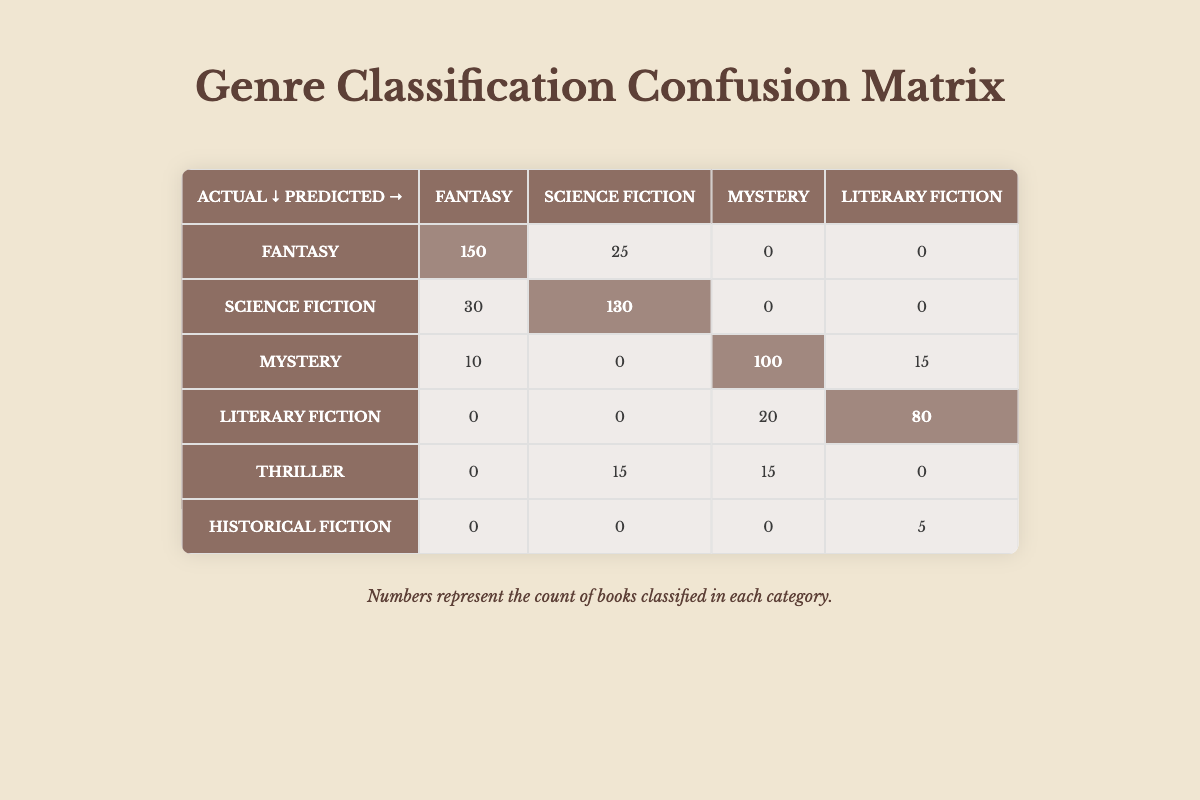What is the count of books that were correctly classified as Fantasy? The matrix indicates that 150 books were predicted as Fantasy and were also actual Fantasy. Therefore, the count of correctly classified Fantasy books is directly from the diagonal element of the matrix.
Answer: 150 What is the total number of books classified as Mystery? To find the total number of books classified as Mystery, we need to sum up all the counts in the Mystery column. This includes 100 (correctly classified), 20 (Literary Fiction predicted as Mystery), and 15 (Thriller predicted as Mystery). Therefore, the total is 100 + 20 + 15 = 135.
Answer: 135 Was the count of Science Fiction books incorrectly classified as Fantasy greater than those incorrectly classified as Mystery? The count of Science Fiction classified as Fantasy is 25, while the count of Science Fiction classified as Mystery is 0. Since 25 is greater than 0, the statement is true.
Answer: Yes What percentage of books in the Literary Fiction category were incorrectly classified? To find this percentage, first, calculate the total number of Literary Fiction: it is 80 (correctly classified) + 15 (Mystery) + 0 (Science Fiction) + 0 (Fantasy) = 95. So, the number of incorrectly classified Literary Fiction is 15. The percentage is (15 / 95) * 100 = 15.79%.
Answer: 15.79% Which genre has the highest misclassification rate based on reader reviews? To determine which genre has the highest misclassification rate, we will calculate the misclassification rate for each genre. For Fantasy: (30 + 10) / (150 + 30 + 10) = 40 / 190 = 21.05%. For Science Fiction: (25 + 15) / (130 + 30 + 15) = 40 / 175 = 22.86%. For Mystery: (20 + 15) / (100 + 20 + 15) = 35 / 135 = 25.93%. For Literary Fiction: (15 + 5) / (80 + 15 + 5) = 20 / 100 = 20%. Hence, Mystery has the highest misclassification rate at 25.93%.
Answer: Mystery What is the total number of Fantasy books that were misclassified? The total number of Fantasy books that were misclassified includes both counts where Fantasy was predicted but the actual genre was different. This includes 30 for Science Fiction and 10 for Mystery—thus the total misclassified is 30 + 10 = 40.
Answer: 40 